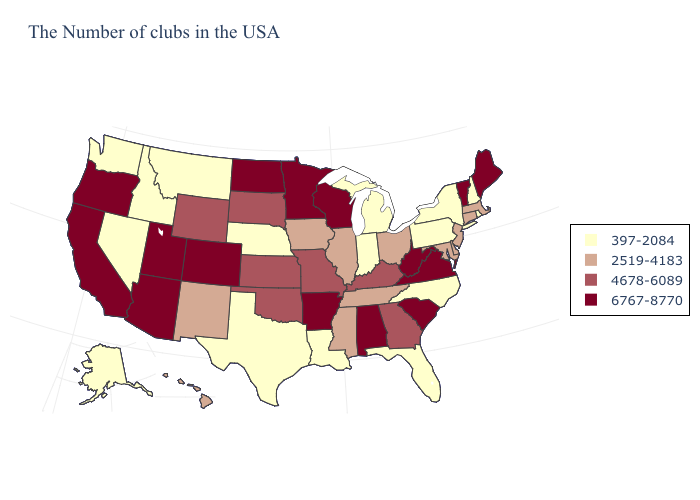What is the lowest value in states that border Pennsylvania?
Give a very brief answer. 397-2084. Name the states that have a value in the range 6767-8770?
Concise answer only. Maine, Vermont, Virginia, South Carolina, West Virginia, Alabama, Wisconsin, Arkansas, Minnesota, North Dakota, Colorado, Utah, Arizona, California, Oregon. Name the states that have a value in the range 4678-6089?
Short answer required. Georgia, Kentucky, Missouri, Kansas, Oklahoma, South Dakota, Wyoming. Does North Carolina have the lowest value in the South?
Give a very brief answer. Yes. What is the highest value in states that border Virginia?
Concise answer only. 6767-8770. Name the states that have a value in the range 6767-8770?
Keep it brief. Maine, Vermont, Virginia, South Carolina, West Virginia, Alabama, Wisconsin, Arkansas, Minnesota, North Dakota, Colorado, Utah, Arizona, California, Oregon. Among the states that border Delaware , does Maryland have the highest value?
Write a very short answer. Yes. How many symbols are there in the legend?
Short answer required. 4. Which states have the highest value in the USA?
Quick response, please. Maine, Vermont, Virginia, South Carolina, West Virginia, Alabama, Wisconsin, Arkansas, Minnesota, North Dakota, Colorado, Utah, Arizona, California, Oregon. What is the value of Nebraska?
Answer briefly. 397-2084. What is the value of Iowa?
Keep it brief. 2519-4183. Among the states that border Mississippi , does Tennessee have the lowest value?
Write a very short answer. No. What is the lowest value in the West?
Answer briefly. 397-2084. Does Minnesota have a lower value than Nebraska?
Answer briefly. No. Among the states that border Connecticut , does Massachusetts have the lowest value?
Quick response, please. No. 